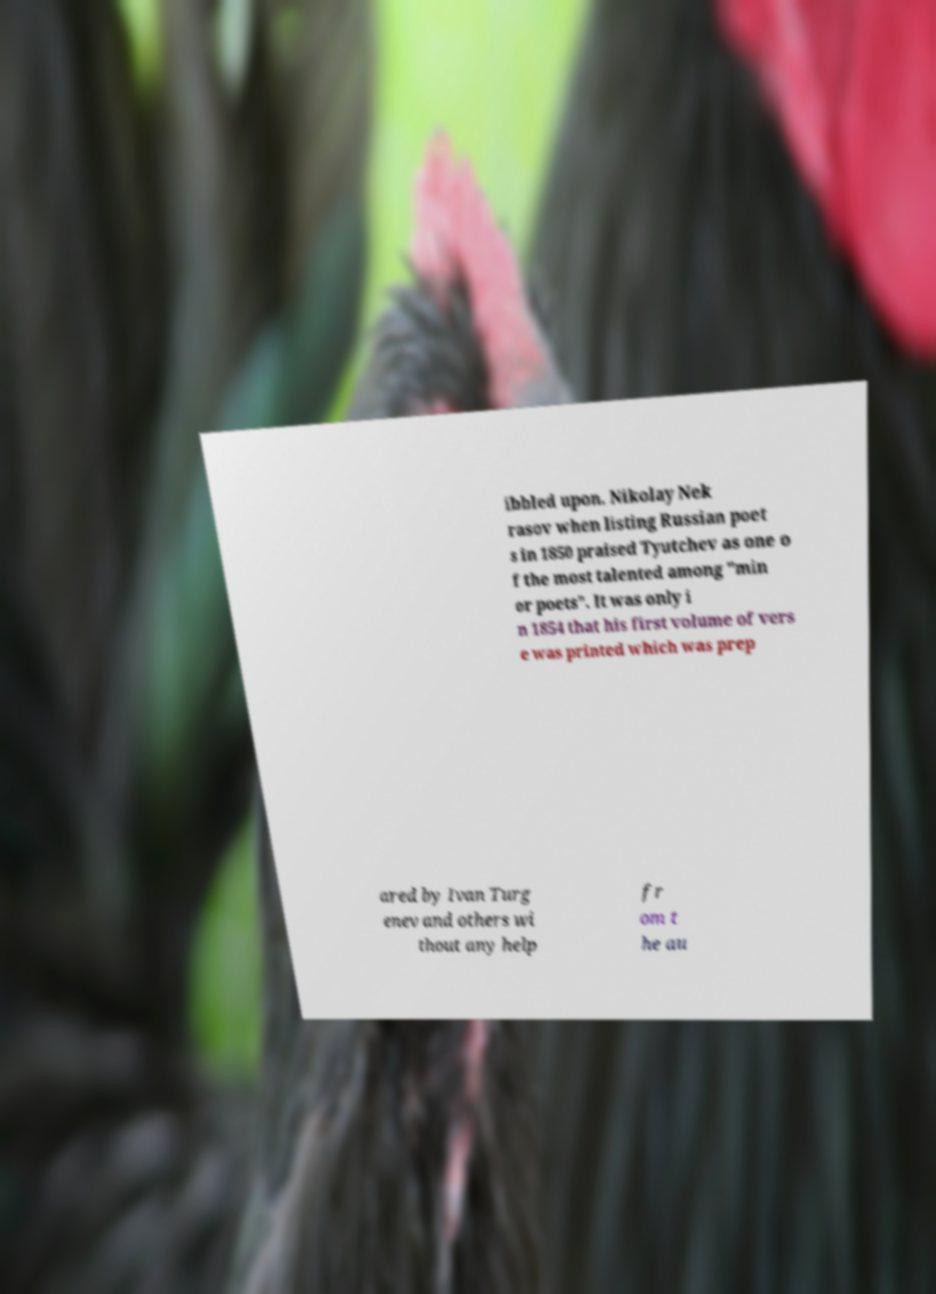For documentation purposes, I need the text within this image transcribed. Could you provide that? ibbled upon. Nikolay Nek rasov when listing Russian poet s in 1850 praised Tyutchev as one o f the most talented among "min or poets". It was only i n 1854 that his first volume of vers e was printed which was prep ared by Ivan Turg enev and others wi thout any help fr om t he au 